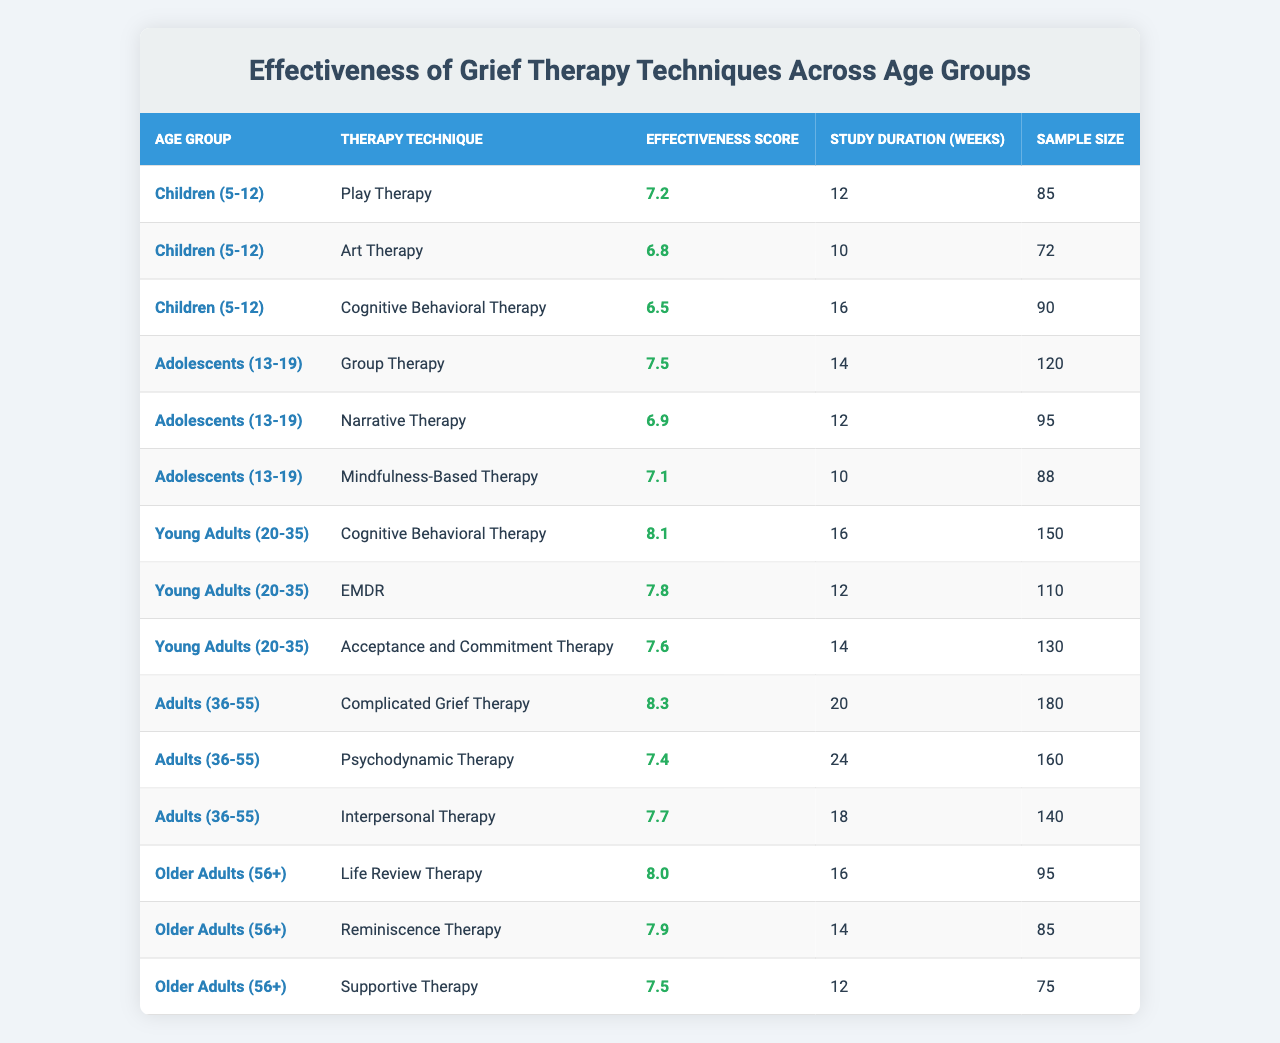What is the effectiveness score of Play Therapy for children? The table shows that the effectiveness score of Play Therapy for the age group "Children (5-12)" is 7.2.
Answer: 7.2 Which therapy technique has the highest effectiveness score for Young Adults (20-35)? Among the listed techniques for Young Adults, Cognitive Behavioral Therapy has the highest effectiveness score of 8.1.
Answer: 8.1 What is the average effectiveness score for therapy techniques used for Older Adults (56+)? The effectiveness scores for Older Adults are 8.0, 7.9, and 7.5. Adding these gives 23.4, and dividing by 3 (number of scores) gives an average of 7.8.
Answer: 7.8 Which therapy technique has the lowest effectiveness score among Adolescents (13-19)? In the Adolescents group, Cognitive Behavioral Therapy has the lowest effectiveness score of 6.5 compared to the other techniques listed (Group Therapy, Narrative Therapy, and Mindfulness-Based Therapy).
Answer: 6.5 Is it true that Art Therapy is more effective than Cognitive Behavioral Therapy for Children (5-12)? Art Therapy has an effectiveness score of 6.8, while Cognitive Behavioral Therapy has a score of 6.5. Since 6.8 is greater than 6.5, the statement is true.
Answer: True What is the total sample size of therapies evaluated for Adults (36-55)? The sample sizes for Adults are 180, 160, and 140. Summing these gives 480 (180 + 160 + 140 = 480).
Answer: 480 Which age group shows the highest score for Complicated Grief Therapy? Complicated Grief Therapy is only listed under the Adults (36-55) age group, with an effectiveness score of 8.3, which is the highest for this technique.
Answer: 8.3 How does the effectiveness of EMDR compare to Acceptance and Commitment Therapy for Young Adults (20-35)? EMDR has an effectiveness score of 7.8 while Acceptance and Commitment Therapy has a score of 7.6. Therefore, EMDR is more effective than Acceptance and Commitment Therapy for this group.
Answer: EMDR is more effective What therapy technique provides the longest study duration for Adults (36-55)? Among the techniques listed for Adults, Psychodynamic Therapy has the longest study duration of 24 weeks.
Answer: 24 weeks Which therapy technique for Older Adults has the lowest effectiveness score? In the Older Adults group, Supportive Therapy has the lowest effectiveness score of 7.5 compared to the other techniques (Life Review Therapy and Reminiscence Therapy).
Answer: 7.5 